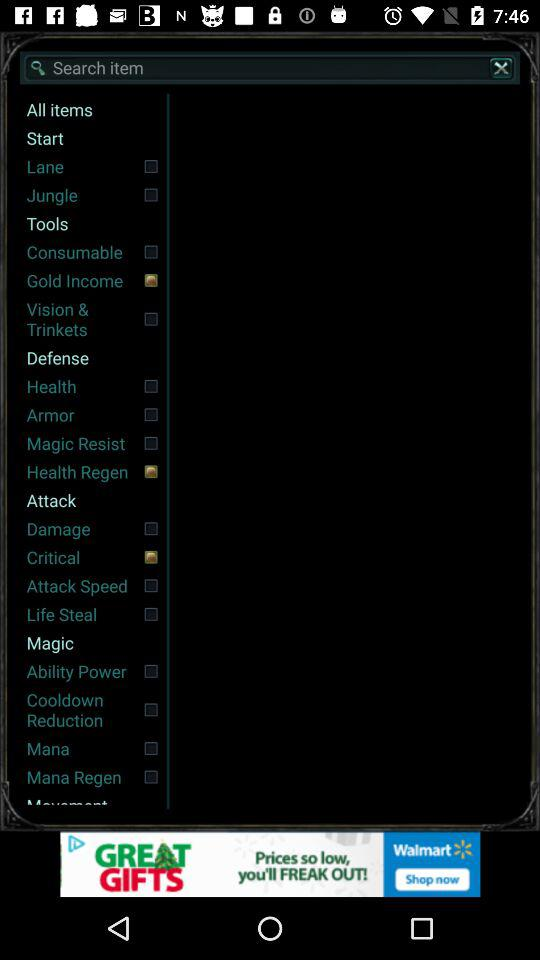What are the selected items? The selected items are "Gold Income", "Health Regen" and "Critical". 